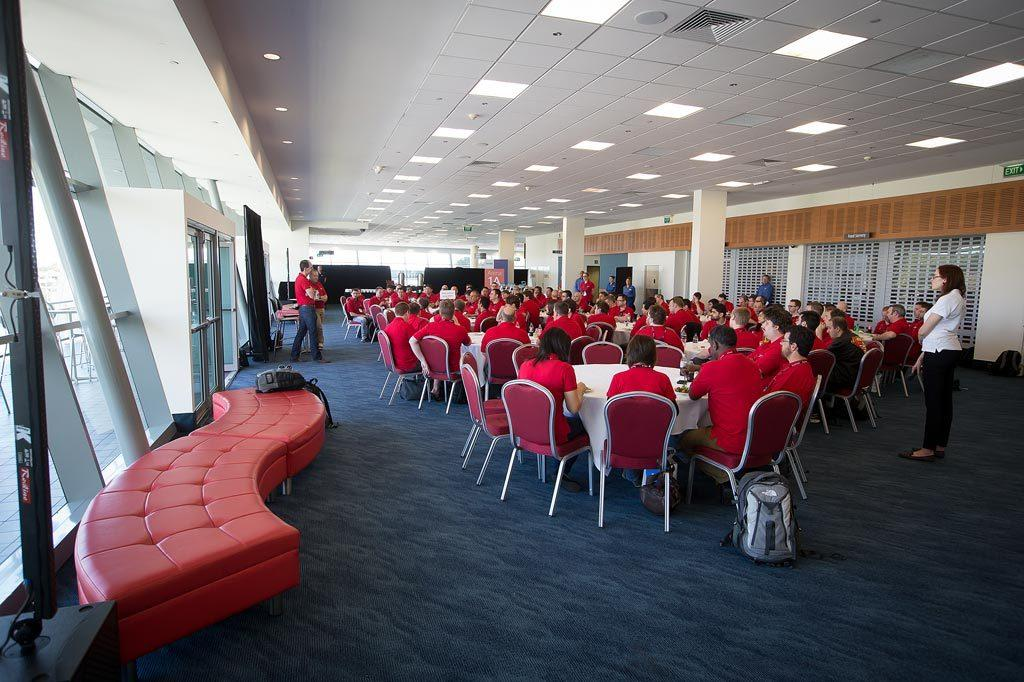How many people are in the image? There is a group of people in the image, but the exact number cannot be determined from the provided facts. What are the people in the image doing? Some people are seated on chairs, while others are standing. What object can be seen in the image besides the people? There is a bag in the image. What can be seen providing illumination in the image? There are lights in the image. What is the weight of the hall in the image? There is no hall present in the image, so it is not possible to determine its weight. 